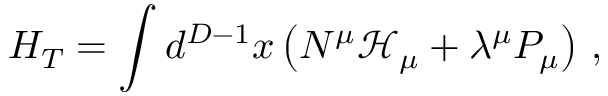Convert formula to latex. <formula><loc_0><loc_0><loc_500><loc_500>H _ { T } = \int d ^ { D - 1 } x \left ( N ^ { \mu } \mathcal { H } _ { \mu } + \lambda ^ { \mu } P _ { \mu } \right ) \, ,</formula> 